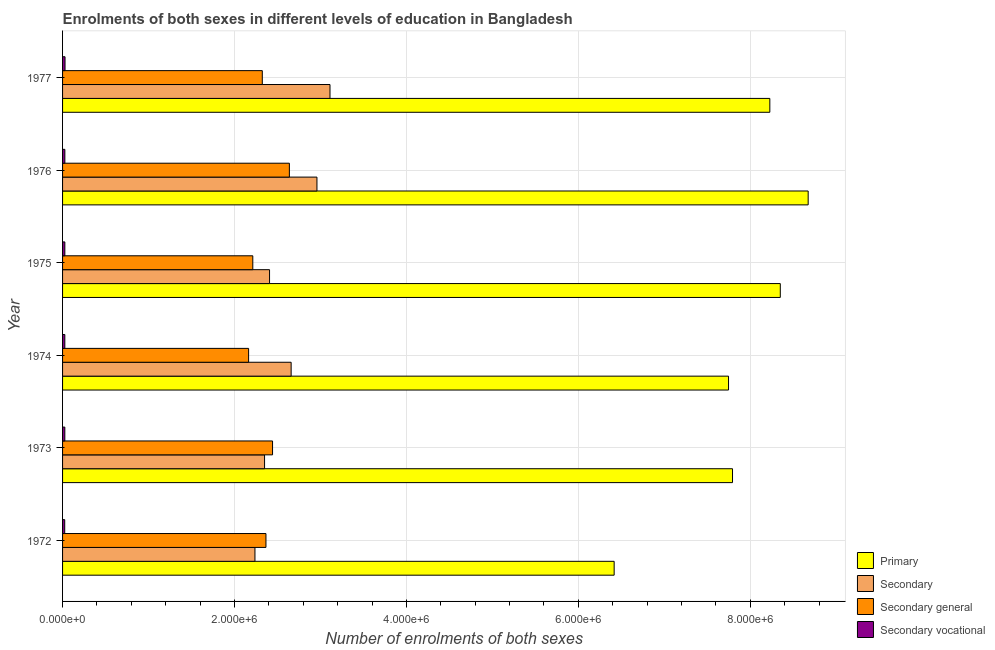Are the number of bars on each tick of the Y-axis equal?
Your response must be concise. Yes. How many bars are there on the 1st tick from the bottom?
Provide a succinct answer. 4. In how many cases, is the number of bars for a given year not equal to the number of legend labels?
Offer a terse response. 0. What is the number of enrolments in secondary vocational education in 1973?
Keep it short and to the point. 2.63e+04. Across all years, what is the maximum number of enrolments in secondary vocational education?
Ensure brevity in your answer.  2.87e+04. Across all years, what is the minimum number of enrolments in secondary education?
Ensure brevity in your answer.  2.24e+06. In which year was the number of enrolments in secondary vocational education minimum?
Provide a short and direct response. 1972. What is the total number of enrolments in secondary general education in the graph?
Provide a short and direct response. 1.41e+07. What is the difference between the number of enrolments in secondary general education in 1973 and that in 1974?
Make the answer very short. 2.79e+05. What is the difference between the number of enrolments in primary education in 1977 and the number of enrolments in secondary education in 1974?
Your response must be concise. 5.57e+06. What is the average number of enrolments in secondary education per year?
Offer a very short reply. 2.62e+06. In the year 1972, what is the difference between the number of enrolments in secondary vocational education and number of enrolments in secondary general education?
Offer a terse response. -2.34e+06. Is the difference between the number of enrolments in secondary general education in 1972 and 1975 greater than the difference between the number of enrolments in primary education in 1972 and 1975?
Provide a succinct answer. Yes. What is the difference between the highest and the second highest number of enrolments in primary education?
Give a very brief answer. 3.24e+05. What is the difference between the highest and the lowest number of enrolments in primary education?
Keep it short and to the point. 2.26e+06. Is it the case that in every year, the sum of the number of enrolments in secondary education and number of enrolments in secondary vocational education is greater than the sum of number of enrolments in primary education and number of enrolments in secondary general education?
Offer a very short reply. No. What does the 1st bar from the top in 1972 represents?
Your response must be concise. Secondary vocational. What does the 3rd bar from the bottom in 1977 represents?
Provide a short and direct response. Secondary general. Is it the case that in every year, the sum of the number of enrolments in primary education and number of enrolments in secondary education is greater than the number of enrolments in secondary general education?
Offer a very short reply. Yes. How many bars are there?
Give a very brief answer. 24. What is the difference between two consecutive major ticks on the X-axis?
Offer a terse response. 2.00e+06. Does the graph contain any zero values?
Your answer should be compact. No. Does the graph contain grids?
Provide a short and direct response. Yes. Where does the legend appear in the graph?
Provide a succinct answer. Bottom right. How many legend labels are there?
Provide a short and direct response. 4. How are the legend labels stacked?
Make the answer very short. Vertical. What is the title of the graph?
Keep it short and to the point. Enrolments of both sexes in different levels of education in Bangladesh. Does "Public sector management" appear as one of the legend labels in the graph?
Your response must be concise. No. What is the label or title of the X-axis?
Ensure brevity in your answer.  Number of enrolments of both sexes. What is the label or title of the Y-axis?
Your answer should be compact. Year. What is the Number of enrolments of both sexes in Primary in 1972?
Offer a very short reply. 6.42e+06. What is the Number of enrolments of both sexes in Secondary in 1972?
Keep it short and to the point. 2.24e+06. What is the Number of enrolments of both sexes of Secondary general in 1972?
Your answer should be very brief. 2.37e+06. What is the Number of enrolments of both sexes of Secondary vocational in 1972?
Make the answer very short. 2.51e+04. What is the Number of enrolments of both sexes in Primary in 1973?
Your answer should be very brief. 7.79e+06. What is the Number of enrolments of both sexes of Secondary in 1973?
Offer a very short reply. 2.35e+06. What is the Number of enrolments of both sexes in Secondary general in 1973?
Your answer should be compact. 2.44e+06. What is the Number of enrolments of both sexes in Secondary vocational in 1973?
Offer a very short reply. 2.63e+04. What is the Number of enrolments of both sexes in Primary in 1974?
Provide a succinct answer. 7.75e+06. What is the Number of enrolments of both sexes of Secondary in 1974?
Give a very brief answer. 2.66e+06. What is the Number of enrolments of both sexes in Secondary general in 1974?
Your answer should be very brief. 2.16e+06. What is the Number of enrolments of both sexes in Secondary vocational in 1974?
Provide a succinct answer. 2.63e+04. What is the Number of enrolments of both sexes in Primary in 1975?
Your answer should be compact. 8.35e+06. What is the Number of enrolments of both sexes in Secondary in 1975?
Offer a very short reply. 2.41e+06. What is the Number of enrolments of both sexes in Secondary general in 1975?
Your answer should be compact. 2.21e+06. What is the Number of enrolments of both sexes of Secondary vocational in 1975?
Make the answer very short. 2.65e+04. What is the Number of enrolments of both sexes in Primary in 1976?
Your answer should be very brief. 8.67e+06. What is the Number of enrolments of both sexes in Secondary in 1976?
Keep it short and to the point. 2.96e+06. What is the Number of enrolments of both sexes in Secondary general in 1976?
Make the answer very short. 2.64e+06. What is the Number of enrolments of both sexes in Secondary vocational in 1976?
Give a very brief answer. 2.67e+04. What is the Number of enrolments of both sexes of Primary in 1977?
Make the answer very short. 8.23e+06. What is the Number of enrolments of both sexes in Secondary in 1977?
Ensure brevity in your answer.  3.11e+06. What is the Number of enrolments of both sexes of Secondary general in 1977?
Give a very brief answer. 2.32e+06. What is the Number of enrolments of both sexes in Secondary vocational in 1977?
Provide a succinct answer. 2.87e+04. Across all years, what is the maximum Number of enrolments of both sexes of Primary?
Provide a succinct answer. 8.67e+06. Across all years, what is the maximum Number of enrolments of both sexes of Secondary?
Provide a short and direct response. 3.11e+06. Across all years, what is the maximum Number of enrolments of both sexes of Secondary general?
Give a very brief answer. 2.64e+06. Across all years, what is the maximum Number of enrolments of both sexes of Secondary vocational?
Provide a succinct answer. 2.87e+04. Across all years, what is the minimum Number of enrolments of both sexes of Primary?
Your response must be concise. 6.42e+06. Across all years, what is the minimum Number of enrolments of both sexes of Secondary?
Your response must be concise. 2.24e+06. Across all years, what is the minimum Number of enrolments of both sexes in Secondary general?
Ensure brevity in your answer.  2.16e+06. Across all years, what is the minimum Number of enrolments of both sexes of Secondary vocational?
Offer a very short reply. 2.51e+04. What is the total Number of enrolments of both sexes of Primary in the graph?
Your answer should be very brief. 4.72e+07. What is the total Number of enrolments of both sexes of Secondary in the graph?
Provide a succinct answer. 1.57e+07. What is the total Number of enrolments of both sexes of Secondary general in the graph?
Your answer should be compact. 1.41e+07. What is the total Number of enrolments of both sexes of Secondary vocational in the graph?
Provide a short and direct response. 1.60e+05. What is the difference between the Number of enrolments of both sexes in Primary in 1972 and that in 1973?
Your response must be concise. -1.38e+06. What is the difference between the Number of enrolments of both sexes in Secondary in 1972 and that in 1973?
Offer a terse response. -1.12e+05. What is the difference between the Number of enrolments of both sexes in Secondary general in 1972 and that in 1973?
Your answer should be compact. -7.67e+04. What is the difference between the Number of enrolments of both sexes in Secondary vocational in 1972 and that in 1973?
Keep it short and to the point. -1231. What is the difference between the Number of enrolments of both sexes of Primary in 1972 and that in 1974?
Ensure brevity in your answer.  -1.33e+06. What is the difference between the Number of enrolments of both sexes of Secondary in 1972 and that in 1974?
Provide a short and direct response. -4.21e+05. What is the difference between the Number of enrolments of both sexes in Secondary general in 1972 and that in 1974?
Offer a very short reply. 2.02e+05. What is the difference between the Number of enrolments of both sexes of Secondary vocational in 1972 and that in 1974?
Keep it short and to the point. -1186. What is the difference between the Number of enrolments of both sexes of Primary in 1972 and that in 1975?
Give a very brief answer. -1.93e+06. What is the difference between the Number of enrolments of both sexes of Secondary in 1972 and that in 1975?
Ensure brevity in your answer.  -1.70e+05. What is the difference between the Number of enrolments of both sexes of Secondary general in 1972 and that in 1975?
Provide a short and direct response. 1.53e+05. What is the difference between the Number of enrolments of both sexes of Secondary vocational in 1972 and that in 1975?
Offer a terse response. -1424. What is the difference between the Number of enrolments of both sexes in Primary in 1972 and that in 1976?
Ensure brevity in your answer.  -2.26e+06. What is the difference between the Number of enrolments of both sexes in Secondary in 1972 and that in 1976?
Make the answer very short. -7.21e+05. What is the difference between the Number of enrolments of both sexes in Secondary general in 1972 and that in 1976?
Offer a very short reply. -2.72e+05. What is the difference between the Number of enrolments of both sexes in Secondary vocational in 1972 and that in 1976?
Give a very brief answer. -1558. What is the difference between the Number of enrolments of both sexes in Primary in 1972 and that in 1977?
Make the answer very short. -1.81e+06. What is the difference between the Number of enrolments of both sexes of Secondary in 1972 and that in 1977?
Your answer should be very brief. -8.73e+05. What is the difference between the Number of enrolments of both sexes in Secondary general in 1972 and that in 1977?
Keep it short and to the point. 4.26e+04. What is the difference between the Number of enrolments of both sexes of Secondary vocational in 1972 and that in 1977?
Your answer should be compact. -3562. What is the difference between the Number of enrolments of both sexes in Primary in 1973 and that in 1974?
Ensure brevity in your answer.  4.63e+04. What is the difference between the Number of enrolments of both sexes in Secondary in 1973 and that in 1974?
Provide a short and direct response. -3.09e+05. What is the difference between the Number of enrolments of both sexes of Secondary general in 1973 and that in 1974?
Your answer should be compact. 2.79e+05. What is the difference between the Number of enrolments of both sexes of Secondary vocational in 1973 and that in 1974?
Keep it short and to the point. 45. What is the difference between the Number of enrolments of both sexes in Primary in 1973 and that in 1975?
Ensure brevity in your answer.  -5.56e+05. What is the difference between the Number of enrolments of both sexes in Secondary in 1973 and that in 1975?
Offer a very short reply. -5.80e+04. What is the difference between the Number of enrolments of both sexes in Secondary general in 1973 and that in 1975?
Your answer should be very brief. 2.30e+05. What is the difference between the Number of enrolments of both sexes in Secondary vocational in 1973 and that in 1975?
Keep it short and to the point. -193. What is the difference between the Number of enrolments of both sexes in Primary in 1973 and that in 1976?
Your response must be concise. -8.80e+05. What is the difference between the Number of enrolments of both sexes of Secondary in 1973 and that in 1976?
Give a very brief answer. -6.10e+05. What is the difference between the Number of enrolments of both sexes of Secondary general in 1973 and that in 1976?
Your answer should be compact. -1.96e+05. What is the difference between the Number of enrolments of both sexes in Secondary vocational in 1973 and that in 1976?
Give a very brief answer. -327. What is the difference between the Number of enrolments of both sexes in Primary in 1973 and that in 1977?
Give a very brief answer. -4.34e+05. What is the difference between the Number of enrolments of both sexes of Secondary in 1973 and that in 1977?
Keep it short and to the point. -7.61e+05. What is the difference between the Number of enrolments of both sexes of Secondary general in 1973 and that in 1977?
Ensure brevity in your answer.  1.19e+05. What is the difference between the Number of enrolments of both sexes in Secondary vocational in 1973 and that in 1977?
Provide a succinct answer. -2331. What is the difference between the Number of enrolments of both sexes in Primary in 1974 and that in 1975?
Your answer should be compact. -6.02e+05. What is the difference between the Number of enrolments of both sexes in Secondary in 1974 and that in 1975?
Provide a succinct answer. 2.51e+05. What is the difference between the Number of enrolments of both sexes of Secondary general in 1974 and that in 1975?
Your answer should be very brief. -4.87e+04. What is the difference between the Number of enrolments of both sexes of Secondary vocational in 1974 and that in 1975?
Your answer should be very brief. -238. What is the difference between the Number of enrolments of both sexes of Primary in 1974 and that in 1976?
Give a very brief answer. -9.26e+05. What is the difference between the Number of enrolments of both sexes of Secondary in 1974 and that in 1976?
Provide a succinct answer. -3.00e+05. What is the difference between the Number of enrolments of both sexes in Secondary general in 1974 and that in 1976?
Keep it short and to the point. -4.74e+05. What is the difference between the Number of enrolments of both sexes in Secondary vocational in 1974 and that in 1976?
Give a very brief answer. -372. What is the difference between the Number of enrolments of both sexes in Primary in 1974 and that in 1977?
Your answer should be compact. -4.80e+05. What is the difference between the Number of enrolments of both sexes in Secondary in 1974 and that in 1977?
Offer a very short reply. -4.52e+05. What is the difference between the Number of enrolments of both sexes of Secondary general in 1974 and that in 1977?
Offer a terse response. -1.59e+05. What is the difference between the Number of enrolments of both sexes in Secondary vocational in 1974 and that in 1977?
Ensure brevity in your answer.  -2376. What is the difference between the Number of enrolments of both sexes of Primary in 1975 and that in 1976?
Provide a succinct answer. -3.24e+05. What is the difference between the Number of enrolments of both sexes in Secondary in 1975 and that in 1976?
Keep it short and to the point. -5.52e+05. What is the difference between the Number of enrolments of both sexes in Secondary general in 1975 and that in 1976?
Make the answer very short. -4.25e+05. What is the difference between the Number of enrolments of both sexes of Secondary vocational in 1975 and that in 1976?
Your answer should be very brief. -134. What is the difference between the Number of enrolments of both sexes of Primary in 1975 and that in 1977?
Your answer should be compact. 1.22e+05. What is the difference between the Number of enrolments of both sexes in Secondary in 1975 and that in 1977?
Offer a terse response. -7.03e+05. What is the difference between the Number of enrolments of both sexes in Secondary general in 1975 and that in 1977?
Make the answer very short. -1.11e+05. What is the difference between the Number of enrolments of both sexes of Secondary vocational in 1975 and that in 1977?
Your answer should be very brief. -2138. What is the difference between the Number of enrolments of both sexes in Primary in 1976 and that in 1977?
Provide a succinct answer. 4.46e+05. What is the difference between the Number of enrolments of both sexes of Secondary in 1976 and that in 1977?
Offer a terse response. -1.52e+05. What is the difference between the Number of enrolments of both sexes of Secondary general in 1976 and that in 1977?
Make the answer very short. 3.15e+05. What is the difference between the Number of enrolments of both sexes of Secondary vocational in 1976 and that in 1977?
Your answer should be compact. -2004. What is the difference between the Number of enrolments of both sexes of Primary in 1972 and the Number of enrolments of both sexes of Secondary in 1973?
Your answer should be compact. 4.07e+06. What is the difference between the Number of enrolments of both sexes in Primary in 1972 and the Number of enrolments of both sexes in Secondary general in 1973?
Offer a terse response. 3.97e+06. What is the difference between the Number of enrolments of both sexes of Primary in 1972 and the Number of enrolments of both sexes of Secondary vocational in 1973?
Provide a succinct answer. 6.39e+06. What is the difference between the Number of enrolments of both sexes of Secondary in 1972 and the Number of enrolments of both sexes of Secondary general in 1973?
Ensure brevity in your answer.  -2.05e+05. What is the difference between the Number of enrolments of both sexes of Secondary in 1972 and the Number of enrolments of both sexes of Secondary vocational in 1973?
Ensure brevity in your answer.  2.21e+06. What is the difference between the Number of enrolments of both sexes in Secondary general in 1972 and the Number of enrolments of both sexes in Secondary vocational in 1973?
Ensure brevity in your answer.  2.34e+06. What is the difference between the Number of enrolments of both sexes of Primary in 1972 and the Number of enrolments of both sexes of Secondary in 1974?
Provide a succinct answer. 3.76e+06. What is the difference between the Number of enrolments of both sexes of Primary in 1972 and the Number of enrolments of both sexes of Secondary general in 1974?
Give a very brief answer. 4.25e+06. What is the difference between the Number of enrolments of both sexes of Primary in 1972 and the Number of enrolments of both sexes of Secondary vocational in 1974?
Make the answer very short. 6.39e+06. What is the difference between the Number of enrolments of both sexes of Secondary in 1972 and the Number of enrolments of both sexes of Secondary general in 1974?
Offer a terse response. 7.39e+04. What is the difference between the Number of enrolments of both sexes of Secondary in 1972 and the Number of enrolments of both sexes of Secondary vocational in 1974?
Provide a succinct answer. 2.21e+06. What is the difference between the Number of enrolments of both sexes in Secondary general in 1972 and the Number of enrolments of both sexes in Secondary vocational in 1974?
Offer a terse response. 2.34e+06. What is the difference between the Number of enrolments of both sexes of Primary in 1972 and the Number of enrolments of both sexes of Secondary in 1975?
Keep it short and to the point. 4.01e+06. What is the difference between the Number of enrolments of both sexes in Primary in 1972 and the Number of enrolments of both sexes in Secondary general in 1975?
Give a very brief answer. 4.20e+06. What is the difference between the Number of enrolments of both sexes in Primary in 1972 and the Number of enrolments of both sexes in Secondary vocational in 1975?
Offer a very short reply. 6.39e+06. What is the difference between the Number of enrolments of both sexes in Secondary in 1972 and the Number of enrolments of both sexes in Secondary general in 1975?
Offer a very short reply. 2.51e+04. What is the difference between the Number of enrolments of both sexes in Secondary in 1972 and the Number of enrolments of both sexes in Secondary vocational in 1975?
Offer a terse response. 2.21e+06. What is the difference between the Number of enrolments of both sexes in Secondary general in 1972 and the Number of enrolments of both sexes in Secondary vocational in 1975?
Provide a short and direct response. 2.34e+06. What is the difference between the Number of enrolments of both sexes in Primary in 1972 and the Number of enrolments of both sexes in Secondary in 1976?
Give a very brief answer. 3.46e+06. What is the difference between the Number of enrolments of both sexes of Primary in 1972 and the Number of enrolments of both sexes of Secondary general in 1976?
Provide a succinct answer. 3.78e+06. What is the difference between the Number of enrolments of both sexes of Primary in 1972 and the Number of enrolments of both sexes of Secondary vocational in 1976?
Your response must be concise. 6.39e+06. What is the difference between the Number of enrolments of both sexes in Secondary in 1972 and the Number of enrolments of both sexes in Secondary general in 1976?
Give a very brief answer. -4.00e+05. What is the difference between the Number of enrolments of both sexes in Secondary in 1972 and the Number of enrolments of both sexes in Secondary vocational in 1976?
Offer a terse response. 2.21e+06. What is the difference between the Number of enrolments of both sexes in Secondary general in 1972 and the Number of enrolments of both sexes in Secondary vocational in 1976?
Your answer should be compact. 2.34e+06. What is the difference between the Number of enrolments of both sexes in Primary in 1972 and the Number of enrolments of both sexes in Secondary in 1977?
Provide a short and direct response. 3.31e+06. What is the difference between the Number of enrolments of both sexes in Primary in 1972 and the Number of enrolments of both sexes in Secondary general in 1977?
Offer a very short reply. 4.09e+06. What is the difference between the Number of enrolments of both sexes of Primary in 1972 and the Number of enrolments of both sexes of Secondary vocational in 1977?
Make the answer very short. 6.39e+06. What is the difference between the Number of enrolments of both sexes in Secondary in 1972 and the Number of enrolments of both sexes in Secondary general in 1977?
Make the answer very short. -8.54e+04. What is the difference between the Number of enrolments of both sexes of Secondary in 1972 and the Number of enrolments of both sexes of Secondary vocational in 1977?
Ensure brevity in your answer.  2.21e+06. What is the difference between the Number of enrolments of both sexes of Secondary general in 1972 and the Number of enrolments of both sexes of Secondary vocational in 1977?
Make the answer very short. 2.34e+06. What is the difference between the Number of enrolments of both sexes in Primary in 1973 and the Number of enrolments of both sexes in Secondary in 1974?
Your answer should be compact. 5.13e+06. What is the difference between the Number of enrolments of both sexes of Primary in 1973 and the Number of enrolments of both sexes of Secondary general in 1974?
Your answer should be compact. 5.63e+06. What is the difference between the Number of enrolments of both sexes in Primary in 1973 and the Number of enrolments of both sexes in Secondary vocational in 1974?
Your answer should be compact. 7.77e+06. What is the difference between the Number of enrolments of both sexes of Secondary in 1973 and the Number of enrolments of both sexes of Secondary general in 1974?
Provide a short and direct response. 1.86e+05. What is the difference between the Number of enrolments of both sexes of Secondary in 1973 and the Number of enrolments of both sexes of Secondary vocational in 1974?
Your answer should be very brief. 2.32e+06. What is the difference between the Number of enrolments of both sexes of Secondary general in 1973 and the Number of enrolments of both sexes of Secondary vocational in 1974?
Provide a succinct answer. 2.42e+06. What is the difference between the Number of enrolments of both sexes of Primary in 1973 and the Number of enrolments of both sexes of Secondary in 1975?
Make the answer very short. 5.39e+06. What is the difference between the Number of enrolments of both sexes in Primary in 1973 and the Number of enrolments of both sexes in Secondary general in 1975?
Offer a very short reply. 5.58e+06. What is the difference between the Number of enrolments of both sexes in Primary in 1973 and the Number of enrolments of both sexes in Secondary vocational in 1975?
Provide a short and direct response. 7.77e+06. What is the difference between the Number of enrolments of both sexes in Secondary in 1973 and the Number of enrolments of both sexes in Secondary general in 1975?
Your response must be concise. 1.37e+05. What is the difference between the Number of enrolments of both sexes in Secondary in 1973 and the Number of enrolments of both sexes in Secondary vocational in 1975?
Offer a terse response. 2.32e+06. What is the difference between the Number of enrolments of both sexes in Secondary general in 1973 and the Number of enrolments of both sexes in Secondary vocational in 1975?
Ensure brevity in your answer.  2.42e+06. What is the difference between the Number of enrolments of both sexes in Primary in 1973 and the Number of enrolments of both sexes in Secondary in 1976?
Your answer should be very brief. 4.83e+06. What is the difference between the Number of enrolments of both sexes in Primary in 1973 and the Number of enrolments of both sexes in Secondary general in 1976?
Ensure brevity in your answer.  5.16e+06. What is the difference between the Number of enrolments of both sexes of Primary in 1973 and the Number of enrolments of both sexes of Secondary vocational in 1976?
Give a very brief answer. 7.77e+06. What is the difference between the Number of enrolments of both sexes of Secondary in 1973 and the Number of enrolments of both sexes of Secondary general in 1976?
Give a very brief answer. -2.89e+05. What is the difference between the Number of enrolments of both sexes in Secondary in 1973 and the Number of enrolments of both sexes in Secondary vocational in 1976?
Your answer should be very brief. 2.32e+06. What is the difference between the Number of enrolments of both sexes in Secondary general in 1973 and the Number of enrolments of both sexes in Secondary vocational in 1976?
Offer a terse response. 2.42e+06. What is the difference between the Number of enrolments of both sexes in Primary in 1973 and the Number of enrolments of both sexes in Secondary in 1977?
Provide a succinct answer. 4.68e+06. What is the difference between the Number of enrolments of both sexes of Primary in 1973 and the Number of enrolments of both sexes of Secondary general in 1977?
Provide a succinct answer. 5.47e+06. What is the difference between the Number of enrolments of both sexes of Primary in 1973 and the Number of enrolments of both sexes of Secondary vocational in 1977?
Your answer should be very brief. 7.77e+06. What is the difference between the Number of enrolments of both sexes of Secondary in 1973 and the Number of enrolments of both sexes of Secondary general in 1977?
Make the answer very short. 2.63e+04. What is the difference between the Number of enrolments of both sexes of Secondary in 1973 and the Number of enrolments of both sexes of Secondary vocational in 1977?
Offer a very short reply. 2.32e+06. What is the difference between the Number of enrolments of both sexes in Secondary general in 1973 and the Number of enrolments of both sexes in Secondary vocational in 1977?
Provide a short and direct response. 2.41e+06. What is the difference between the Number of enrolments of both sexes in Primary in 1974 and the Number of enrolments of both sexes in Secondary in 1975?
Your response must be concise. 5.34e+06. What is the difference between the Number of enrolments of both sexes of Primary in 1974 and the Number of enrolments of both sexes of Secondary general in 1975?
Your response must be concise. 5.53e+06. What is the difference between the Number of enrolments of both sexes of Primary in 1974 and the Number of enrolments of both sexes of Secondary vocational in 1975?
Give a very brief answer. 7.72e+06. What is the difference between the Number of enrolments of both sexes of Secondary in 1974 and the Number of enrolments of both sexes of Secondary general in 1975?
Ensure brevity in your answer.  4.46e+05. What is the difference between the Number of enrolments of both sexes of Secondary in 1974 and the Number of enrolments of both sexes of Secondary vocational in 1975?
Offer a terse response. 2.63e+06. What is the difference between the Number of enrolments of both sexes of Secondary general in 1974 and the Number of enrolments of both sexes of Secondary vocational in 1975?
Your answer should be very brief. 2.14e+06. What is the difference between the Number of enrolments of both sexes in Primary in 1974 and the Number of enrolments of both sexes in Secondary in 1976?
Ensure brevity in your answer.  4.79e+06. What is the difference between the Number of enrolments of both sexes of Primary in 1974 and the Number of enrolments of both sexes of Secondary general in 1976?
Ensure brevity in your answer.  5.11e+06. What is the difference between the Number of enrolments of both sexes of Primary in 1974 and the Number of enrolments of both sexes of Secondary vocational in 1976?
Offer a very short reply. 7.72e+06. What is the difference between the Number of enrolments of both sexes in Secondary in 1974 and the Number of enrolments of both sexes in Secondary general in 1976?
Keep it short and to the point. 2.07e+04. What is the difference between the Number of enrolments of both sexes of Secondary in 1974 and the Number of enrolments of both sexes of Secondary vocational in 1976?
Give a very brief answer. 2.63e+06. What is the difference between the Number of enrolments of both sexes of Secondary general in 1974 and the Number of enrolments of both sexes of Secondary vocational in 1976?
Your answer should be compact. 2.14e+06. What is the difference between the Number of enrolments of both sexes of Primary in 1974 and the Number of enrolments of both sexes of Secondary in 1977?
Provide a short and direct response. 4.64e+06. What is the difference between the Number of enrolments of both sexes of Primary in 1974 and the Number of enrolments of both sexes of Secondary general in 1977?
Offer a terse response. 5.42e+06. What is the difference between the Number of enrolments of both sexes in Primary in 1974 and the Number of enrolments of both sexes in Secondary vocational in 1977?
Your response must be concise. 7.72e+06. What is the difference between the Number of enrolments of both sexes of Secondary in 1974 and the Number of enrolments of both sexes of Secondary general in 1977?
Your answer should be compact. 3.36e+05. What is the difference between the Number of enrolments of both sexes in Secondary in 1974 and the Number of enrolments of both sexes in Secondary vocational in 1977?
Offer a terse response. 2.63e+06. What is the difference between the Number of enrolments of both sexes in Secondary general in 1974 and the Number of enrolments of both sexes in Secondary vocational in 1977?
Give a very brief answer. 2.14e+06. What is the difference between the Number of enrolments of both sexes in Primary in 1975 and the Number of enrolments of both sexes in Secondary in 1976?
Offer a terse response. 5.39e+06. What is the difference between the Number of enrolments of both sexes in Primary in 1975 and the Number of enrolments of both sexes in Secondary general in 1976?
Offer a terse response. 5.71e+06. What is the difference between the Number of enrolments of both sexes in Primary in 1975 and the Number of enrolments of both sexes in Secondary vocational in 1976?
Provide a succinct answer. 8.32e+06. What is the difference between the Number of enrolments of both sexes in Secondary in 1975 and the Number of enrolments of both sexes in Secondary general in 1976?
Make the answer very short. -2.31e+05. What is the difference between the Number of enrolments of both sexes of Secondary in 1975 and the Number of enrolments of both sexes of Secondary vocational in 1976?
Your answer should be very brief. 2.38e+06. What is the difference between the Number of enrolments of both sexes in Secondary general in 1975 and the Number of enrolments of both sexes in Secondary vocational in 1976?
Make the answer very short. 2.19e+06. What is the difference between the Number of enrolments of both sexes in Primary in 1975 and the Number of enrolments of both sexes in Secondary in 1977?
Provide a succinct answer. 5.24e+06. What is the difference between the Number of enrolments of both sexes in Primary in 1975 and the Number of enrolments of both sexes in Secondary general in 1977?
Offer a very short reply. 6.03e+06. What is the difference between the Number of enrolments of both sexes of Primary in 1975 and the Number of enrolments of both sexes of Secondary vocational in 1977?
Give a very brief answer. 8.32e+06. What is the difference between the Number of enrolments of both sexes of Secondary in 1975 and the Number of enrolments of both sexes of Secondary general in 1977?
Give a very brief answer. 8.43e+04. What is the difference between the Number of enrolments of both sexes in Secondary in 1975 and the Number of enrolments of both sexes in Secondary vocational in 1977?
Offer a very short reply. 2.38e+06. What is the difference between the Number of enrolments of both sexes of Secondary general in 1975 and the Number of enrolments of both sexes of Secondary vocational in 1977?
Give a very brief answer. 2.18e+06. What is the difference between the Number of enrolments of both sexes of Primary in 1976 and the Number of enrolments of both sexes of Secondary in 1977?
Provide a succinct answer. 5.56e+06. What is the difference between the Number of enrolments of both sexes of Primary in 1976 and the Number of enrolments of both sexes of Secondary general in 1977?
Your answer should be very brief. 6.35e+06. What is the difference between the Number of enrolments of both sexes in Primary in 1976 and the Number of enrolments of both sexes in Secondary vocational in 1977?
Ensure brevity in your answer.  8.65e+06. What is the difference between the Number of enrolments of both sexes in Secondary in 1976 and the Number of enrolments of both sexes in Secondary general in 1977?
Provide a succinct answer. 6.36e+05. What is the difference between the Number of enrolments of both sexes of Secondary in 1976 and the Number of enrolments of both sexes of Secondary vocational in 1977?
Ensure brevity in your answer.  2.93e+06. What is the difference between the Number of enrolments of both sexes of Secondary general in 1976 and the Number of enrolments of both sexes of Secondary vocational in 1977?
Offer a terse response. 2.61e+06. What is the average Number of enrolments of both sexes in Primary per year?
Ensure brevity in your answer.  7.87e+06. What is the average Number of enrolments of both sexes in Secondary per year?
Your response must be concise. 2.62e+06. What is the average Number of enrolments of both sexes of Secondary general per year?
Your response must be concise. 2.36e+06. What is the average Number of enrolments of both sexes of Secondary vocational per year?
Keep it short and to the point. 2.66e+04. In the year 1972, what is the difference between the Number of enrolments of both sexes in Primary and Number of enrolments of both sexes in Secondary?
Give a very brief answer. 4.18e+06. In the year 1972, what is the difference between the Number of enrolments of both sexes in Primary and Number of enrolments of both sexes in Secondary general?
Give a very brief answer. 4.05e+06. In the year 1972, what is the difference between the Number of enrolments of both sexes of Primary and Number of enrolments of both sexes of Secondary vocational?
Keep it short and to the point. 6.39e+06. In the year 1972, what is the difference between the Number of enrolments of both sexes of Secondary and Number of enrolments of both sexes of Secondary general?
Provide a short and direct response. -1.28e+05. In the year 1972, what is the difference between the Number of enrolments of both sexes in Secondary and Number of enrolments of both sexes in Secondary vocational?
Offer a terse response. 2.21e+06. In the year 1972, what is the difference between the Number of enrolments of both sexes in Secondary general and Number of enrolments of both sexes in Secondary vocational?
Offer a very short reply. 2.34e+06. In the year 1973, what is the difference between the Number of enrolments of both sexes of Primary and Number of enrolments of both sexes of Secondary?
Provide a succinct answer. 5.44e+06. In the year 1973, what is the difference between the Number of enrolments of both sexes of Primary and Number of enrolments of both sexes of Secondary general?
Ensure brevity in your answer.  5.35e+06. In the year 1973, what is the difference between the Number of enrolments of both sexes in Primary and Number of enrolments of both sexes in Secondary vocational?
Provide a succinct answer. 7.77e+06. In the year 1973, what is the difference between the Number of enrolments of both sexes of Secondary and Number of enrolments of both sexes of Secondary general?
Your response must be concise. -9.29e+04. In the year 1973, what is the difference between the Number of enrolments of both sexes of Secondary and Number of enrolments of both sexes of Secondary vocational?
Provide a succinct answer. 2.32e+06. In the year 1973, what is the difference between the Number of enrolments of both sexes of Secondary general and Number of enrolments of both sexes of Secondary vocational?
Provide a short and direct response. 2.42e+06. In the year 1974, what is the difference between the Number of enrolments of both sexes of Primary and Number of enrolments of both sexes of Secondary?
Your answer should be very brief. 5.09e+06. In the year 1974, what is the difference between the Number of enrolments of both sexes in Primary and Number of enrolments of both sexes in Secondary general?
Your answer should be compact. 5.58e+06. In the year 1974, what is the difference between the Number of enrolments of both sexes in Primary and Number of enrolments of both sexes in Secondary vocational?
Offer a terse response. 7.72e+06. In the year 1974, what is the difference between the Number of enrolments of both sexes in Secondary and Number of enrolments of both sexes in Secondary general?
Give a very brief answer. 4.95e+05. In the year 1974, what is the difference between the Number of enrolments of both sexes in Secondary and Number of enrolments of both sexes in Secondary vocational?
Your answer should be very brief. 2.63e+06. In the year 1974, what is the difference between the Number of enrolments of both sexes in Secondary general and Number of enrolments of both sexes in Secondary vocational?
Offer a very short reply. 2.14e+06. In the year 1975, what is the difference between the Number of enrolments of both sexes of Primary and Number of enrolments of both sexes of Secondary?
Keep it short and to the point. 5.94e+06. In the year 1975, what is the difference between the Number of enrolments of both sexes in Primary and Number of enrolments of both sexes in Secondary general?
Provide a short and direct response. 6.14e+06. In the year 1975, what is the difference between the Number of enrolments of both sexes of Primary and Number of enrolments of both sexes of Secondary vocational?
Keep it short and to the point. 8.32e+06. In the year 1975, what is the difference between the Number of enrolments of both sexes in Secondary and Number of enrolments of both sexes in Secondary general?
Offer a very short reply. 1.95e+05. In the year 1975, what is the difference between the Number of enrolments of both sexes of Secondary and Number of enrolments of both sexes of Secondary vocational?
Ensure brevity in your answer.  2.38e+06. In the year 1975, what is the difference between the Number of enrolments of both sexes in Secondary general and Number of enrolments of both sexes in Secondary vocational?
Your response must be concise. 2.19e+06. In the year 1976, what is the difference between the Number of enrolments of both sexes of Primary and Number of enrolments of both sexes of Secondary?
Give a very brief answer. 5.71e+06. In the year 1976, what is the difference between the Number of enrolments of both sexes of Primary and Number of enrolments of both sexes of Secondary general?
Your answer should be very brief. 6.04e+06. In the year 1976, what is the difference between the Number of enrolments of both sexes in Primary and Number of enrolments of both sexes in Secondary vocational?
Your response must be concise. 8.65e+06. In the year 1976, what is the difference between the Number of enrolments of both sexes in Secondary and Number of enrolments of both sexes in Secondary general?
Keep it short and to the point. 3.21e+05. In the year 1976, what is the difference between the Number of enrolments of both sexes in Secondary and Number of enrolments of both sexes in Secondary vocational?
Offer a very short reply. 2.93e+06. In the year 1976, what is the difference between the Number of enrolments of both sexes in Secondary general and Number of enrolments of both sexes in Secondary vocational?
Offer a very short reply. 2.61e+06. In the year 1977, what is the difference between the Number of enrolments of both sexes in Primary and Number of enrolments of both sexes in Secondary?
Provide a succinct answer. 5.12e+06. In the year 1977, what is the difference between the Number of enrolments of both sexes in Primary and Number of enrolments of both sexes in Secondary general?
Your response must be concise. 5.90e+06. In the year 1977, what is the difference between the Number of enrolments of both sexes of Primary and Number of enrolments of both sexes of Secondary vocational?
Your response must be concise. 8.20e+06. In the year 1977, what is the difference between the Number of enrolments of both sexes in Secondary and Number of enrolments of both sexes in Secondary general?
Your response must be concise. 7.88e+05. In the year 1977, what is the difference between the Number of enrolments of both sexes of Secondary and Number of enrolments of both sexes of Secondary vocational?
Provide a succinct answer. 3.08e+06. In the year 1977, what is the difference between the Number of enrolments of both sexes of Secondary general and Number of enrolments of both sexes of Secondary vocational?
Provide a short and direct response. 2.29e+06. What is the ratio of the Number of enrolments of both sexes in Primary in 1972 to that in 1973?
Keep it short and to the point. 0.82. What is the ratio of the Number of enrolments of both sexes in Secondary in 1972 to that in 1973?
Make the answer very short. 0.95. What is the ratio of the Number of enrolments of both sexes of Secondary general in 1972 to that in 1973?
Provide a short and direct response. 0.97. What is the ratio of the Number of enrolments of both sexes of Secondary vocational in 1972 to that in 1973?
Your answer should be compact. 0.95. What is the ratio of the Number of enrolments of both sexes in Primary in 1972 to that in 1974?
Offer a terse response. 0.83. What is the ratio of the Number of enrolments of both sexes in Secondary in 1972 to that in 1974?
Offer a terse response. 0.84. What is the ratio of the Number of enrolments of both sexes in Secondary general in 1972 to that in 1974?
Keep it short and to the point. 1.09. What is the ratio of the Number of enrolments of both sexes in Secondary vocational in 1972 to that in 1974?
Your response must be concise. 0.95. What is the ratio of the Number of enrolments of both sexes of Primary in 1972 to that in 1975?
Ensure brevity in your answer.  0.77. What is the ratio of the Number of enrolments of both sexes in Secondary in 1972 to that in 1975?
Your answer should be very brief. 0.93. What is the ratio of the Number of enrolments of both sexes in Secondary general in 1972 to that in 1975?
Offer a very short reply. 1.07. What is the ratio of the Number of enrolments of both sexes of Secondary vocational in 1972 to that in 1975?
Provide a succinct answer. 0.95. What is the ratio of the Number of enrolments of both sexes in Primary in 1972 to that in 1976?
Your response must be concise. 0.74. What is the ratio of the Number of enrolments of both sexes of Secondary in 1972 to that in 1976?
Offer a terse response. 0.76. What is the ratio of the Number of enrolments of both sexes of Secondary general in 1972 to that in 1976?
Keep it short and to the point. 0.9. What is the ratio of the Number of enrolments of both sexes of Secondary vocational in 1972 to that in 1976?
Your answer should be compact. 0.94. What is the ratio of the Number of enrolments of both sexes in Primary in 1972 to that in 1977?
Your response must be concise. 0.78. What is the ratio of the Number of enrolments of both sexes in Secondary in 1972 to that in 1977?
Your answer should be very brief. 0.72. What is the ratio of the Number of enrolments of both sexes of Secondary general in 1972 to that in 1977?
Provide a short and direct response. 1.02. What is the ratio of the Number of enrolments of both sexes in Secondary vocational in 1972 to that in 1977?
Your answer should be compact. 0.88. What is the ratio of the Number of enrolments of both sexes of Secondary in 1973 to that in 1974?
Keep it short and to the point. 0.88. What is the ratio of the Number of enrolments of both sexes of Secondary general in 1973 to that in 1974?
Give a very brief answer. 1.13. What is the ratio of the Number of enrolments of both sexes of Secondary vocational in 1973 to that in 1974?
Provide a succinct answer. 1. What is the ratio of the Number of enrolments of both sexes of Primary in 1973 to that in 1975?
Provide a succinct answer. 0.93. What is the ratio of the Number of enrolments of both sexes in Secondary in 1973 to that in 1975?
Ensure brevity in your answer.  0.98. What is the ratio of the Number of enrolments of both sexes in Secondary general in 1973 to that in 1975?
Provide a succinct answer. 1.1. What is the ratio of the Number of enrolments of both sexes in Secondary vocational in 1973 to that in 1975?
Give a very brief answer. 0.99. What is the ratio of the Number of enrolments of both sexes of Primary in 1973 to that in 1976?
Offer a very short reply. 0.9. What is the ratio of the Number of enrolments of both sexes of Secondary in 1973 to that in 1976?
Ensure brevity in your answer.  0.79. What is the ratio of the Number of enrolments of both sexes of Secondary general in 1973 to that in 1976?
Ensure brevity in your answer.  0.93. What is the ratio of the Number of enrolments of both sexes of Secondary vocational in 1973 to that in 1976?
Provide a succinct answer. 0.99. What is the ratio of the Number of enrolments of both sexes of Primary in 1973 to that in 1977?
Offer a very short reply. 0.95. What is the ratio of the Number of enrolments of both sexes in Secondary in 1973 to that in 1977?
Make the answer very short. 0.76. What is the ratio of the Number of enrolments of both sexes of Secondary general in 1973 to that in 1977?
Ensure brevity in your answer.  1.05. What is the ratio of the Number of enrolments of both sexes in Secondary vocational in 1973 to that in 1977?
Give a very brief answer. 0.92. What is the ratio of the Number of enrolments of both sexes in Primary in 1974 to that in 1975?
Give a very brief answer. 0.93. What is the ratio of the Number of enrolments of both sexes of Secondary in 1974 to that in 1975?
Offer a very short reply. 1.1. What is the ratio of the Number of enrolments of both sexes in Primary in 1974 to that in 1976?
Make the answer very short. 0.89. What is the ratio of the Number of enrolments of both sexes of Secondary in 1974 to that in 1976?
Give a very brief answer. 0.9. What is the ratio of the Number of enrolments of both sexes in Secondary general in 1974 to that in 1976?
Your answer should be very brief. 0.82. What is the ratio of the Number of enrolments of both sexes in Secondary vocational in 1974 to that in 1976?
Your answer should be compact. 0.99. What is the ratio of the Number of enrolments of both sexes of Primary in 1974 to that in 1977?
Provide a succinct answer. 0.94. What is the ratio of the Number of enrolments of both sexes in Secondary in 1974 to that in 1977?
Provide a succinct answer. 0.85. What is the ratio of the Number of enrolments of both sexes in Secondary general in 1974 to that in 1977?
Provide a succinct answer. 0.93. What is the ratio of the Number of enrolments of both sexes of Secondary vocational in 1974 to that in 1977?
Provide a succinct answer. 0.92. What is the ratio of the Number of enrolments of both sexes of Primary in 1975 to that in 1976?
Make the answer very short. 0.96. What is the ratio of the Number of enrolments of both sexes of Secondary in 1975 to that in 1976?
Make the answer very short. 0.81. What is the ratio of the Number of enrolments of both sexes in Secondary general in 1975 to that in 1976?
Your response must be concise. 0.84. What is the ratio of the Number of enrolments of both sexes of Primary in 1975 to that in 1977?
Give a very brief answer. 1.01. What is the ratio of the Number of enrolments of both sexes of Secondary in 1975 to that in 1977?
Provide a short and direct response. 0.77. What is the ratio of the Number of enrolments of both sexes in Secondary general in 1975 to that in 1977?
Offer a terse response. 0.95. What is the ratio of the Number of enrolments of both sexes in Secondary vocational in 1975 to that in 1977?
Offer a terse response. 0.93. What is the ratio of the Number of enrolments of both sexes of Primary in 1976 to that in 1977?
Offer a terse response. 1.05. What is the ratio of the Number of enrolments of both sexes of Secondary in 1976 to that in 1977?
Keep it short and to the point. 0.95. What is the ratio of the Number of enrolments of both sexes of Secondary general in 1976 to that in 1977?
Your answer should be very brief. 1.14. What is the ratio of the Number of enrolments of both sexes of Secondary vocational in 1976 to that in 1977?
Offer a very short reply. 0.93. What is the difference between the highest and the second highest Number of enrolments of both sexes in Primary?
Offer a very short reply. 3.24e+05. What is the difference between the highest and the second highest Number of enrolments of both sexes in Secondary?
Make the answer very short. 1.52e+05. What is the difference between the highest and the second highest Number of enrolments of both sexes in Secondary general?
Give a very brief answer. 1.96e+05. What is the difference between the highest and the second highest Number of enrolments of both sexes in Secondary vocational?
Provide a succinct answer. 2004. What is the difference between the highest and the lowest Number of enrolments of both sexes of Primary?
Give a very brief answer. 2.26e+06. What is the difference between the highest and the lowest Number of enrolments of both sexes in Secondary?
Offer a terse response. 8.73e+05. What is the difference between the highest and the lowest Number of enrolments of both sexes of Secondary general?
Ensure brevity in your answer.  4.74e+05. What is the difference between the highest and the lowest Number of enrolments of both sexes in Secondary vocational?
Provide a short and direct response. 3562. 